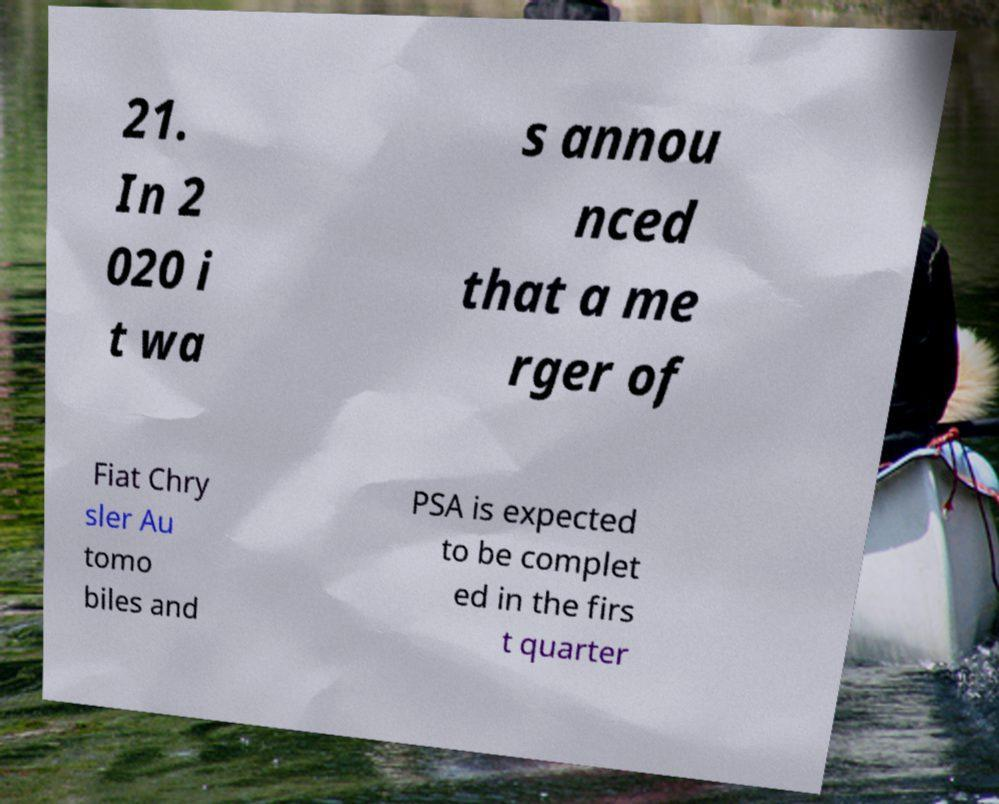Could you extract and type out the text from this image? 21. In 2 020 i t wa s annou nced that a me rger of Fiat Chry sler Au tomo biles and PSA is expected to be complet ed in the firs t quarter 